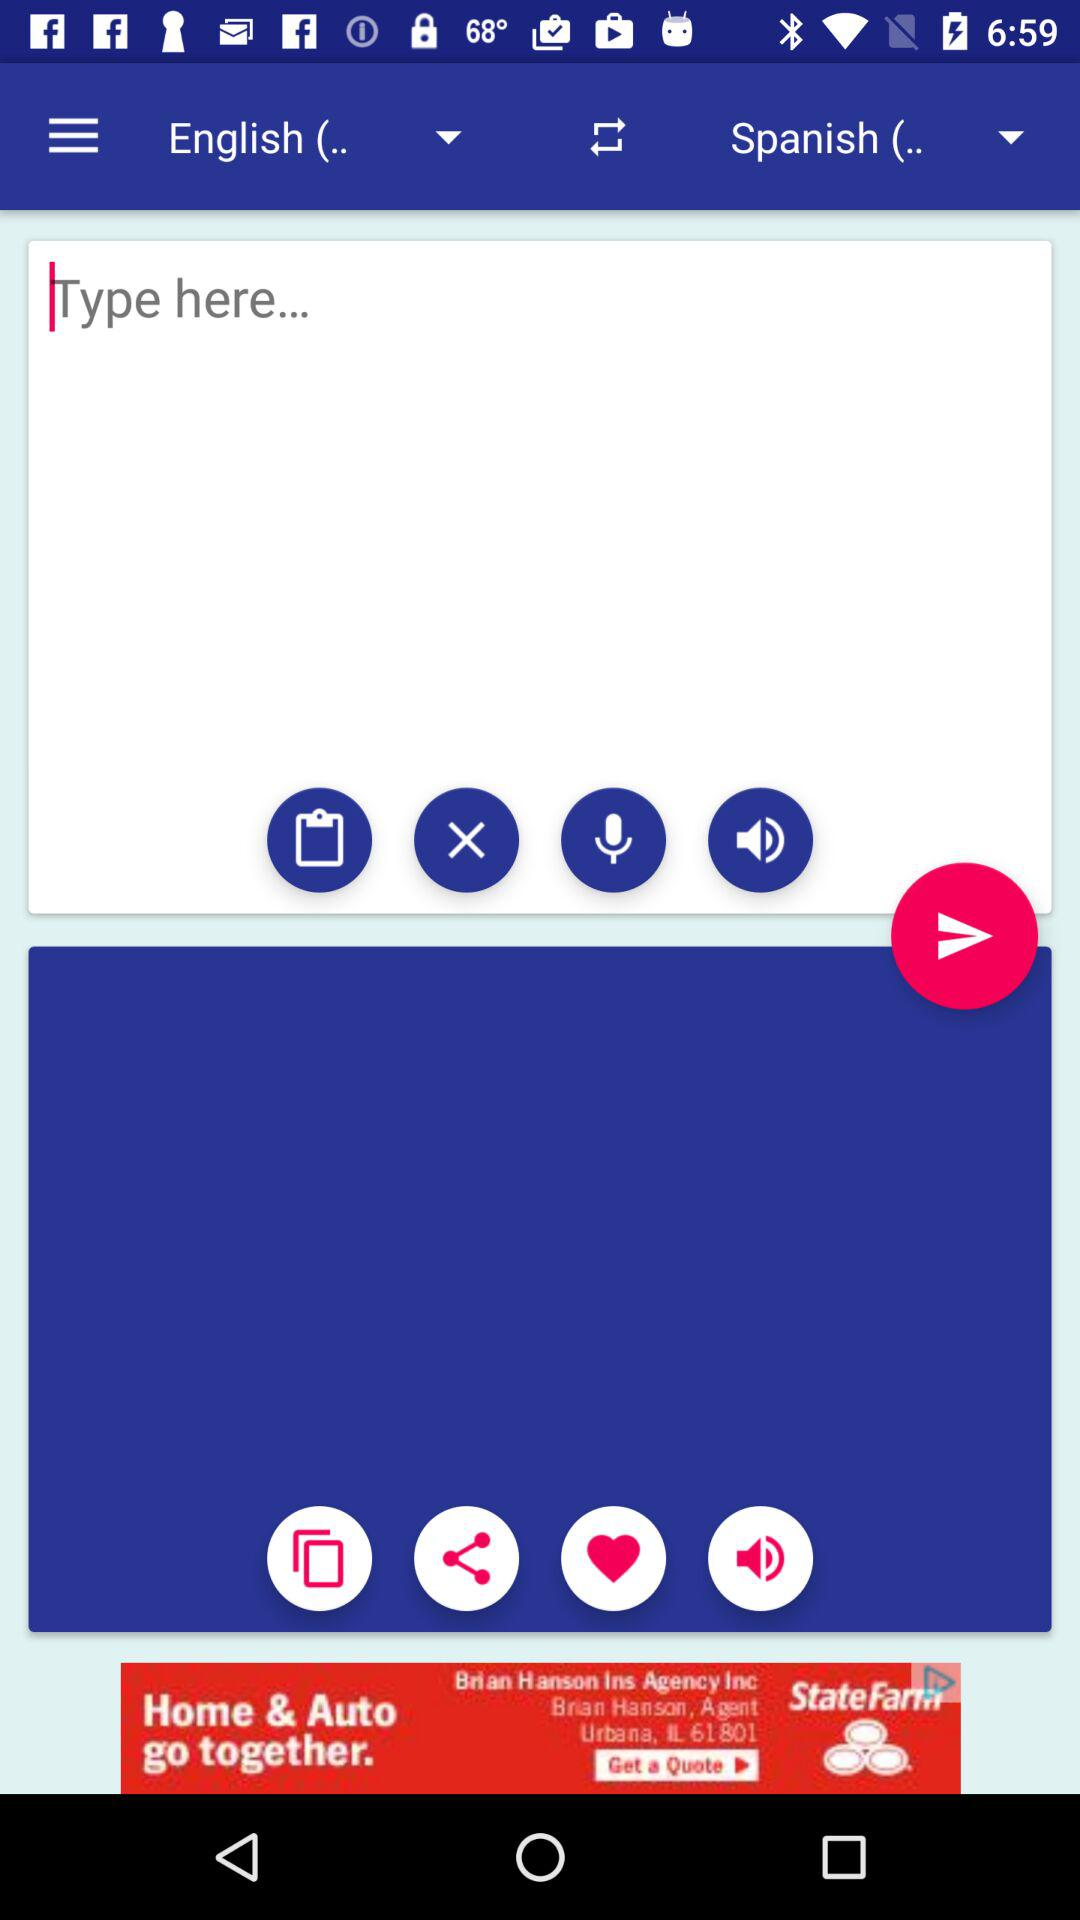How many text elements have language options?
Answer the question using a single word or phrase. 2 